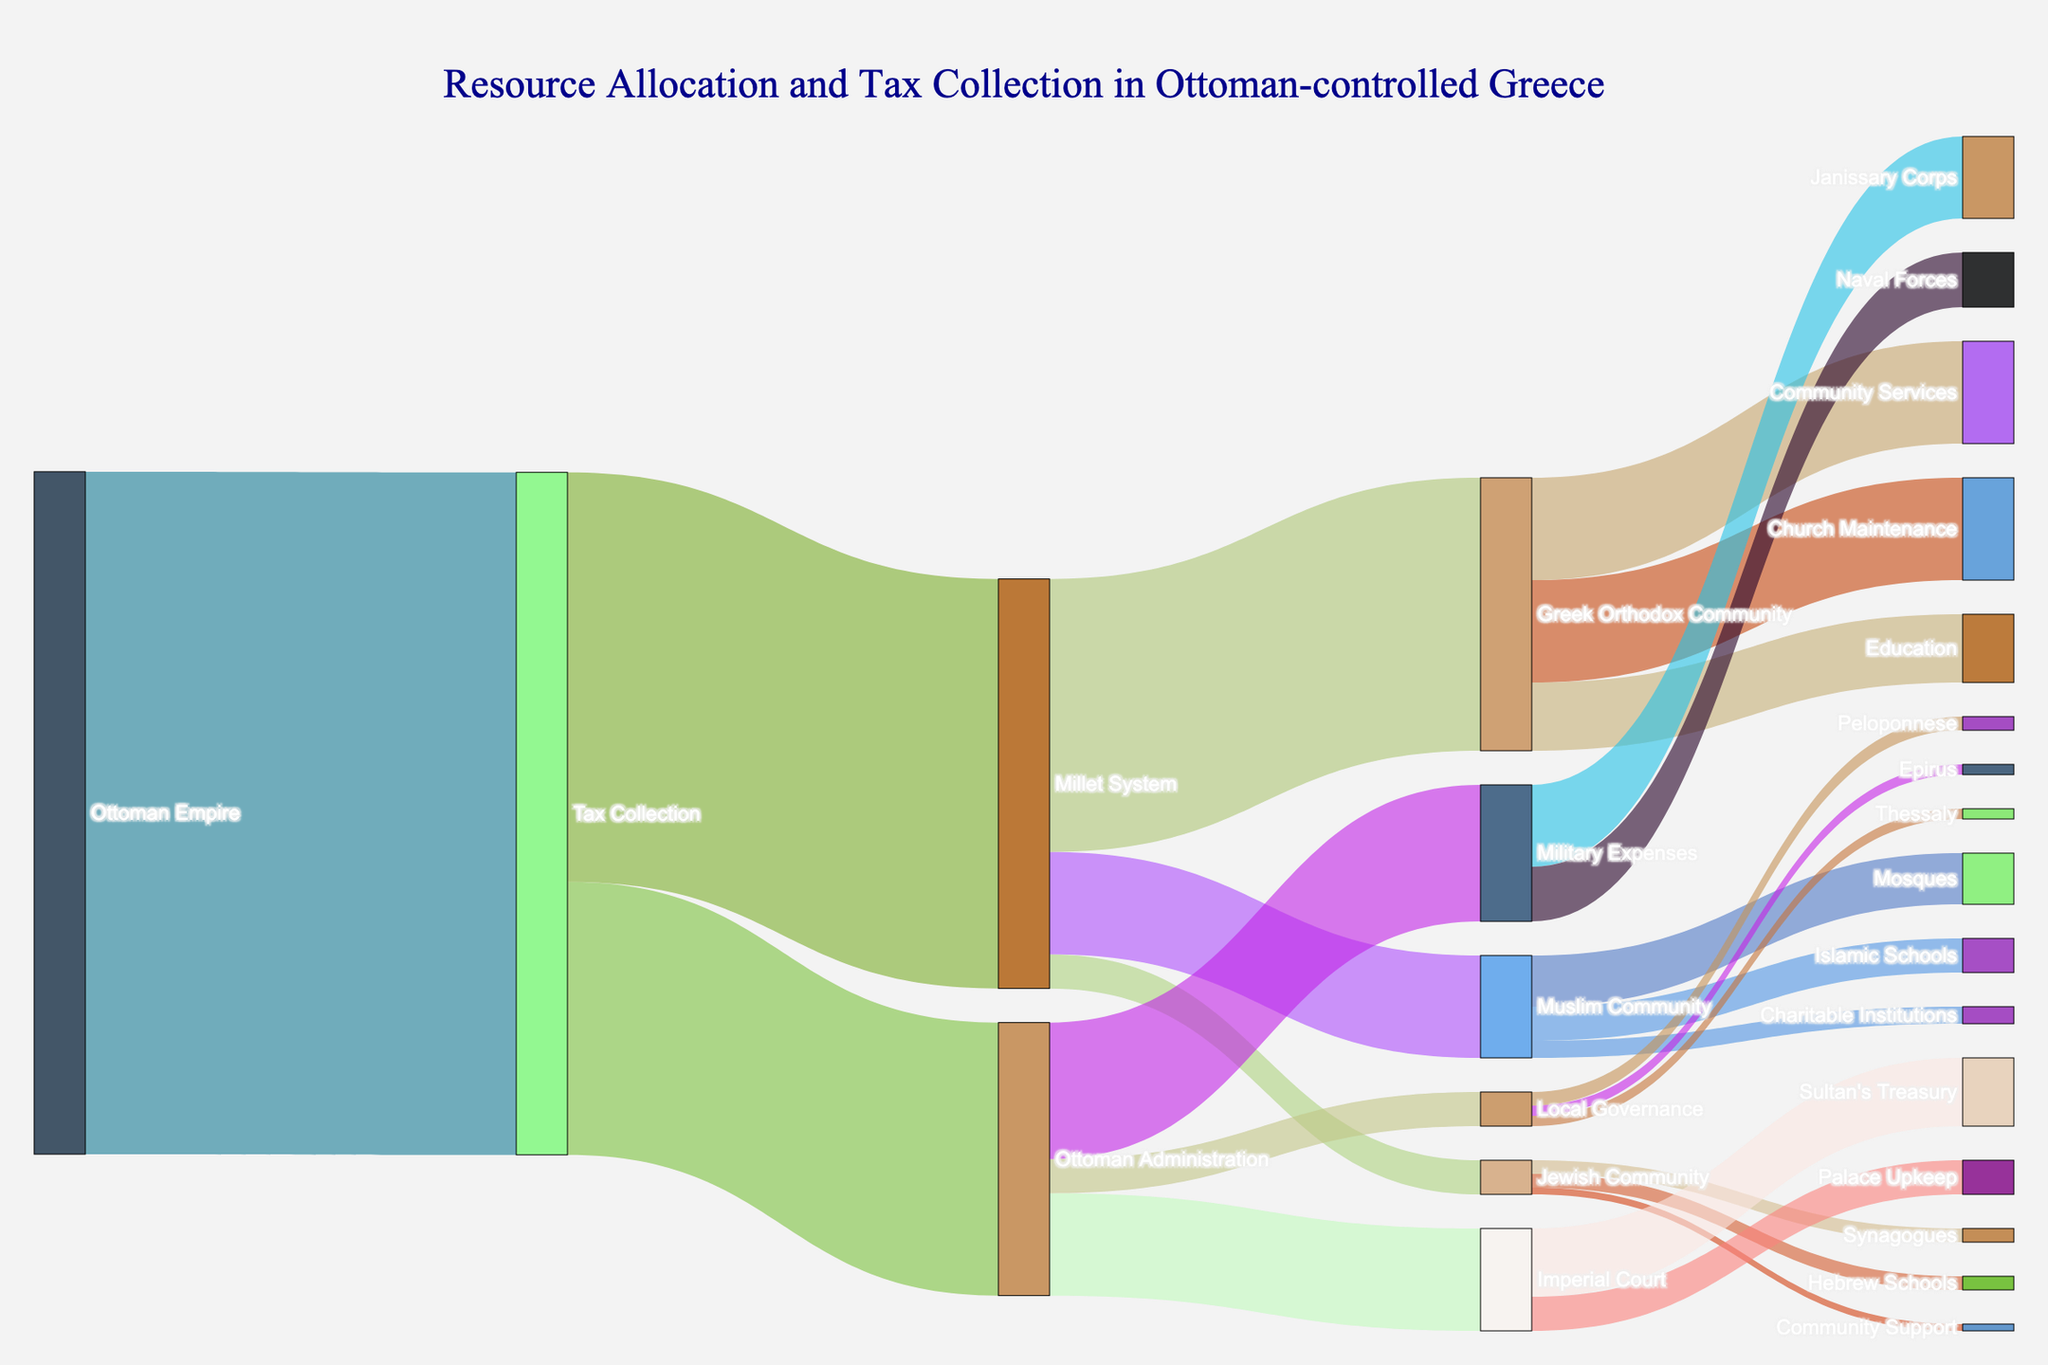what is the title of the plot? The title is displayed at the top center and describes the main subject of the Sankey Diagram.
Answer: Resource Allocation and Tax Collection in Ottoman-controlled Greece which system received the largest portion of tax collection? According to the diagram, the "Millet System" receives the largest amount from tax collection. Visually, the thickness of the flow from Tax Collection to Millet System is the largest.
Answer: Millet System what is the combined allocation for military expenses, imperial court, and local governance from the ottoman administration? We need to sum the values of the flows from Ottoman Administration to Military Expenses (200,000), Imperial Court (150,000), and Local Governance (50,000). 200,000 + 150,000 + 50,000 equals 400,000.
Answer: 400,000 how much more is allocated to the greek orthodox community compared to the muslim community? First, we find the allocation for the Greek Orthodox Community (400,000) and the Muslim Community (150,000). Then we calculate the difference: 400,000 - 150,000 = 250,000.
Answer: 250,000 which region receives the least funding for local governance? By comparing the values for Peloponnese (20,000), Thessaly (15,000), and Epirus (15,000), we see that Thessaly and Epirus are tied for the least funding.
Answer: Thessaly and Epirus what is the percentage of the tax collection allocated to ottoman administration? From the plot, 400,000 is allocated to the Ottoman Administration out of a total tax collection of 1,000,000. The calculation is (400,000 / 1,000,000) * 100% = 40%.
Answer: 40% what is the total allocation for education in greek orthodox and muslim communities? The Greek Orthodox Community allocates 100,000 to Education, and the Muslim Community allocates 50,000 to Islamic Schools. Summing these values, we get 100,000 + 50,000 = 150,000.
Answer: 150,000 which community receives more funding for places of worship, jewish or muslim? The diagram shows that the Jewish Community receives 20,000 for Synagogues, while the Muslim Community receives 75,000 for Mosques. Comparing these values, the Muslim Community receives more.
Answer: Muslim Community what is the largest allocation within the ottoman administration? By observing the flows from Ottoman Administration, we see that Military Expenses (200,000) is the largest allocation in this category.
Answer: Military Expenses what is the smallest single allocation shown in the sankey diagram? The smallest allocation can be observed by identifying the thinnest flow line, which is from the Jewish Community to Community Support, valued at 10,000.
Answer: Community Support, 10,000 